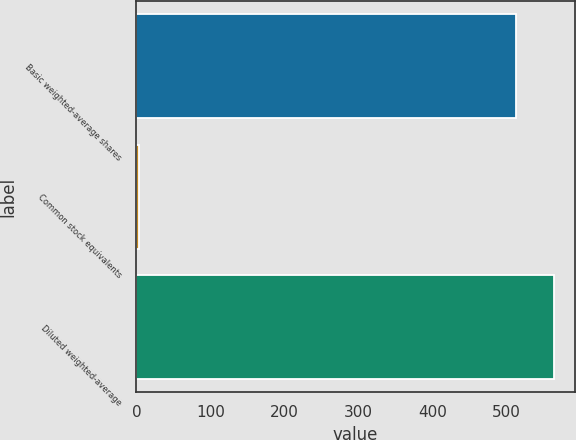Convert chart to OTSL. <chart><loc_0><loc_0><loc_500><loc_500><bar_chart><fcel>Basic weighted-average shares<fcel>Common stock equivalents<fcel>Diluted weighted-average<nl><fcel>512.6<fcel>4.1<fcel>563.86<nl></chart> 